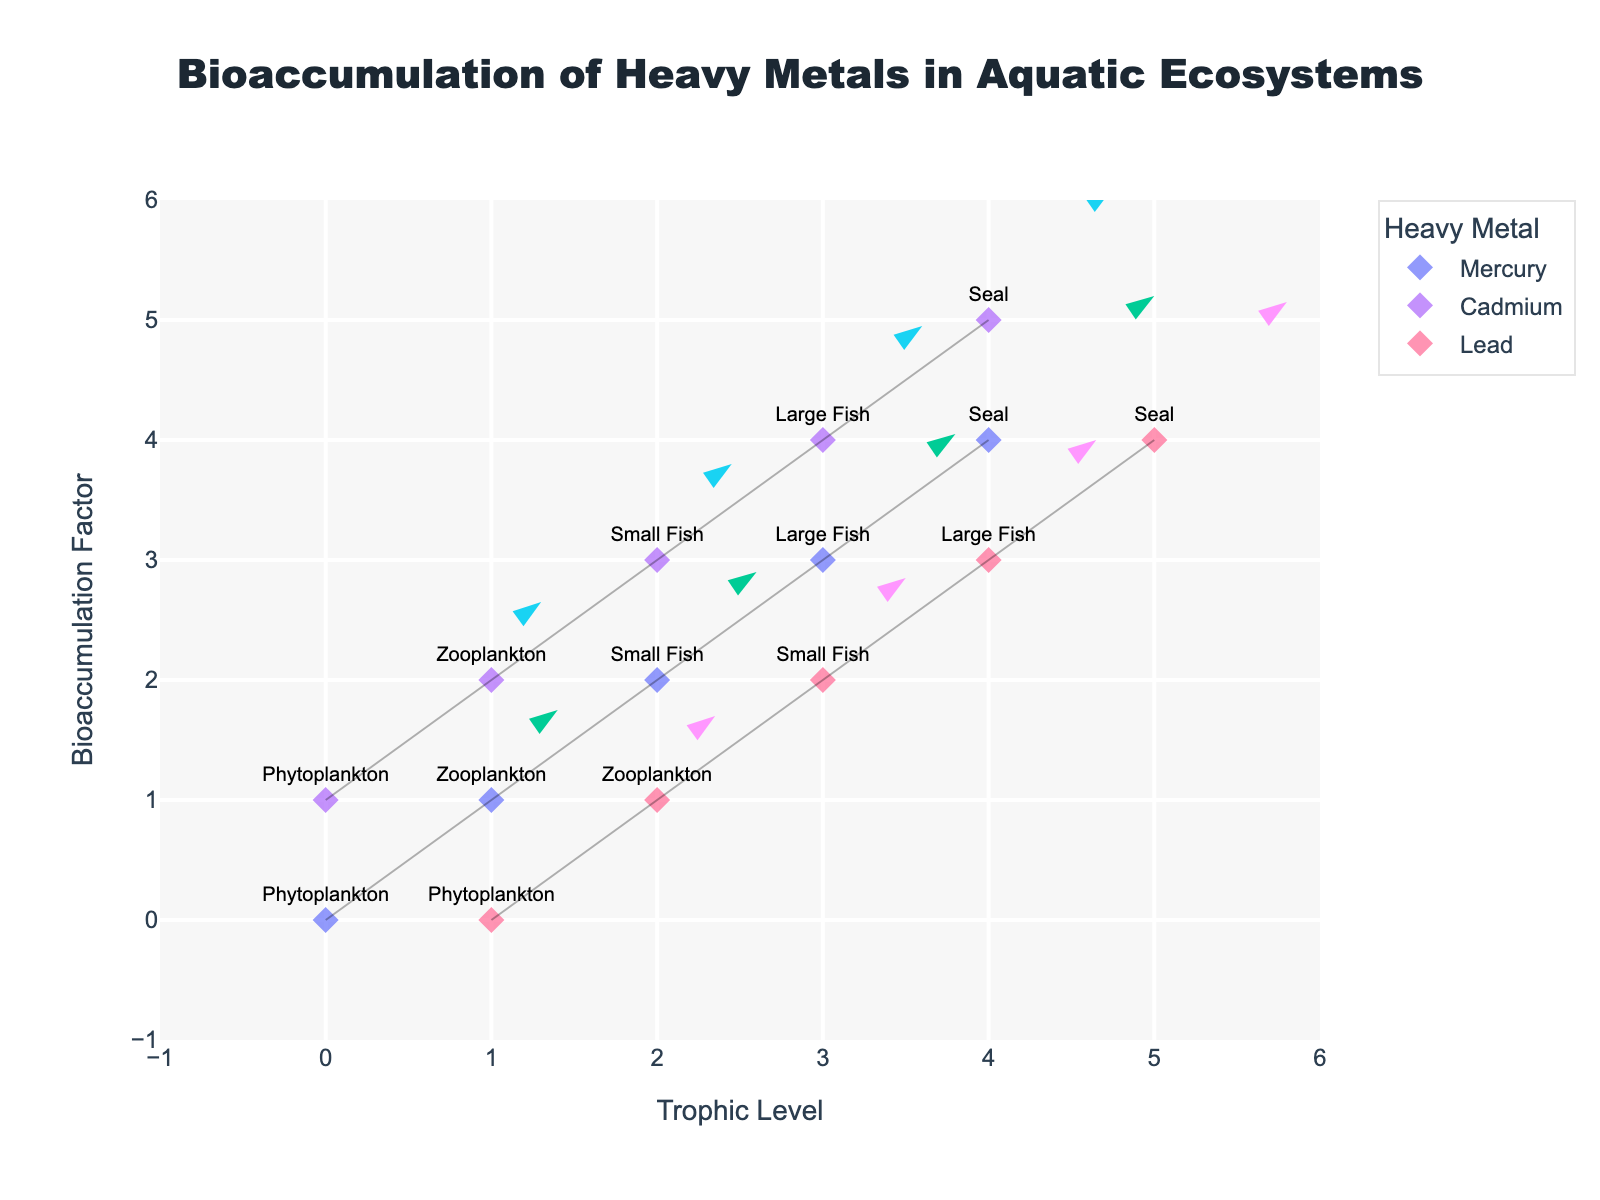Which species is at the lowest trophic level for Mercury? The plot shows different species labeled along the X axis for various metals. At X = 0, labeled Phytoplankton, which is at the lowest trophic level for Mercury.
Answer: Phytoplankton How many trophic levels are represented for Lead in the plot? The plot for Lead shows markers along the X-axis from 1 to 5. Counting these points gives us 5 trophic levels.
Answer: 5 Comparing the bioaccumulation factor of Cadmium in Phytoplankton and Lead in Zooplankton, which is higher? For Cadmium in Phytoplankton (X=0, Y=1), the bioaccumulation factor is 1. For Lead in Zooplankton (X=2, Y=1), the bioaccumulation factor is 1. By comparing Y values, we see Cadmium has a higher factor.
Answer: Cadmium in Phytoplankton What is the total bioaccumulation factor for Mercury across all trophic levels? The sum of the Y-values for Mercury's data points gives the total bioaccumulation factor (0 + 1 + 2 + 3 + 4) = 10.
Answer: 10 What is the average directional change (U and V components) for Cadmium? Calculating the average U and V: U = (0.3 + 0.6 + 0.9 + 1.2 + 1.5)/5 = 0.9, V = (0.9 + 1.3 + 1.6 + 1.9 + 2.2)/5 = 1.58. So, the average directional change is (0.9, 1.58).
Answer: (0.9, 1.58) Which metal shows the highest bioaccumulation factor for the species 'Small Fish'? Looking at the Y-values for Small Fish for each metal: Mercury at Y=2, Cadmium at Y=3, and Lead at Y=2. Cadmium shows the highest value (Y=3).
Answer: Cadmium Does the directional change vector (U, V) become larger or smaller as you move up the trophic levels for Mercury? Observing U and V values for Mercury as we move from (0,0) to (4,4): the (U, V) values increase from (0.5, 1.2) at the lowest level to (2.0, 2.4) at the highest level. This shows an increasing trend.
Answer: Larger Describe the relationship between the bioaccumulation factor and trophic levels for Mercury. As trophic levels increase (moving right on the X-axis from 0 to 4), the bioaccumulation factor (Y-values) also increases from 0 to 4, indicating biomagnification.
Answer: Increasing trend Is there any instance where the directional change vector (U, V) for a higher trophic level is less than that of a lower trophic level for Cadmium? Comparing U and V values for Cadmium across trophic levels: no higher trophic level (X=1 to 5) has (U,V) smaller than a lower level.
Answer: No 